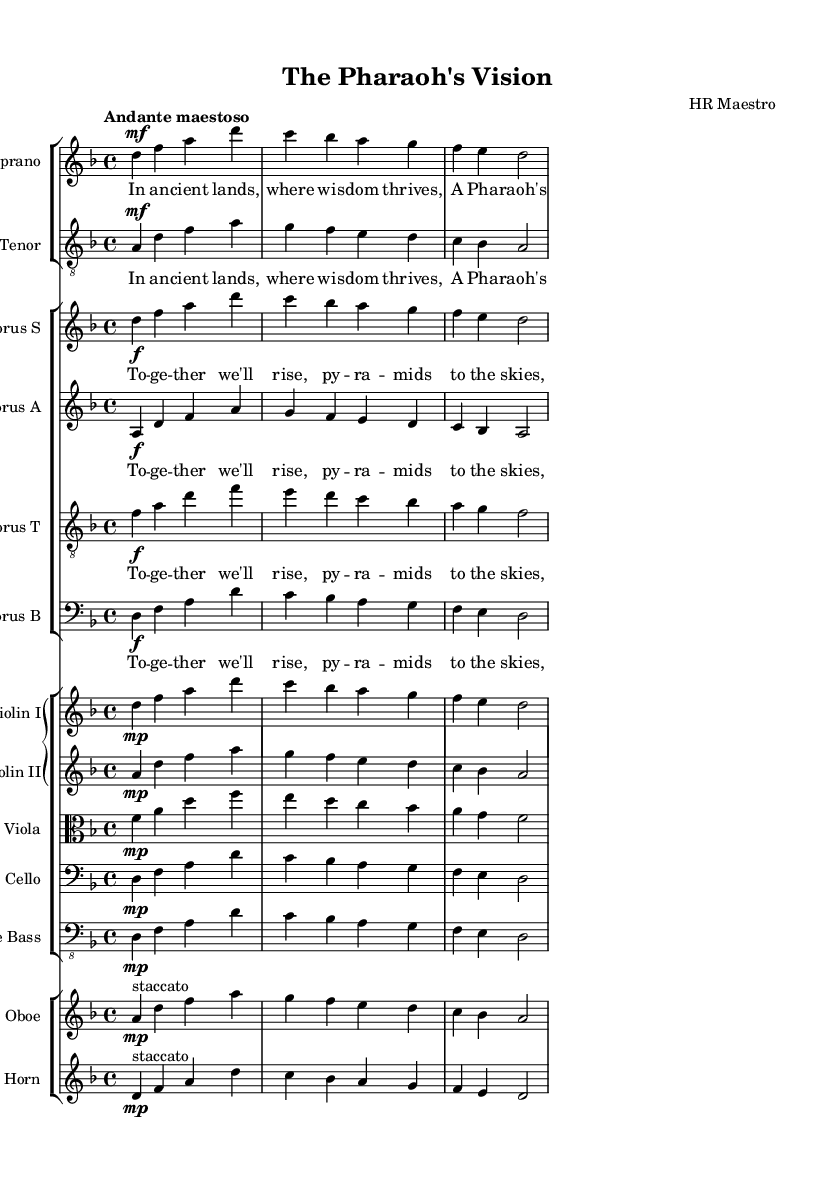What is the key signature of this music? The key signature is indicated at the beginning of the sheet music. In this case, it shows one flat, which represents D minor.
Answer: D minor What is the time signature of this music? The time signature is found at the beginning of the score, represented by the numbers indicating beats per measure. Here, it shows 4 over 4, meaning there are four beats in each measure.
Answer: 4/4 What is the tempo marking for this piece? The tempo is specified at the start of the music, shown in Italian. In this case, "Andante maestoso" indicates a moderately slow pace with a majestic character.
Answer: Andante maestoso How many vocal parts are there in the choir? The choir section indicates a four-part harmony which is evident from the four staves labeled Soprano, Alto, Tenor, and Bass.
Answer: Four What type of opera does this music represent? The title suggests that this opera focuses on themes related to leadership strategies applied in ancient civilizations, emphasizing its dramatic character.
Answer: Dramatic opera Which instruments are included along with the voices? The sheet music provides a detailed score showing specific instruments, including two violins, viola, cello, double bass, oboe, and French horn, along with the vocal parts.
Answer: Violin I, Violin II, Viola, Cello, Double Bass, Oboe, French Horn 